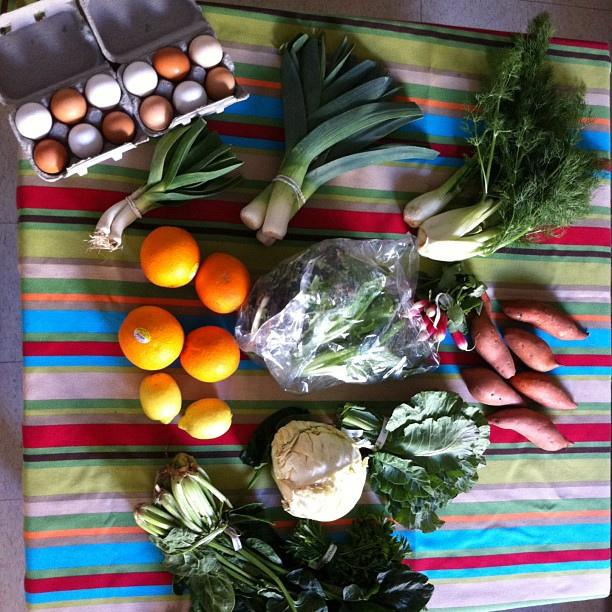What are the objects placed on? Please explain your reasoning. towel. The objects are placed on a brightly colored towel. 